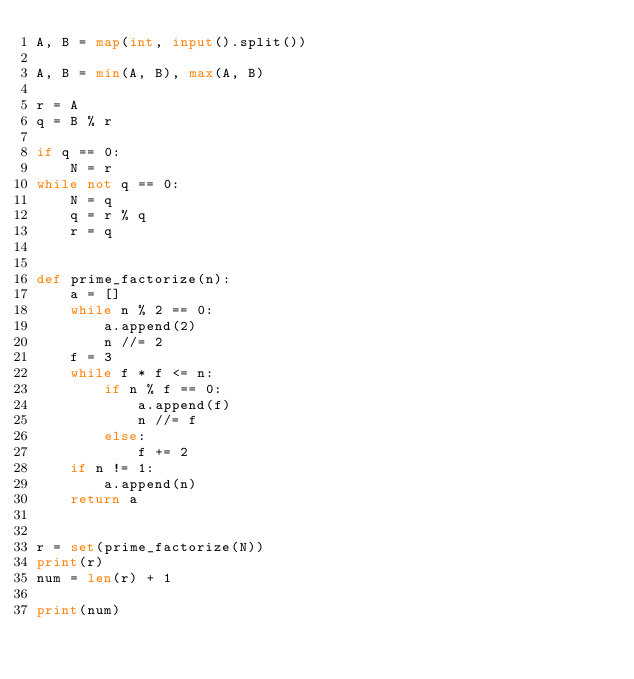<code> <loc_0><loc_0><loc_500><loc_500><_Python_>A, B = map(int, input().split())

A, B = min(A, B), max(A, B)

r = A
q = B % r

if q == 0:
    N = r
while not q == 0:
    N = q
    q = r % q
    r = q


def prime_factorize(n):
    a = []
    while n % 2 == 0:
        a.append(2)
        n //= 2
    f = 3
    while f * f <= n:
        if n % f == 0:
            a.append(f)
            n //= f
        else:
            f += 2
    if n != 1:
        a.append(n)
    return a


r = set(prime_factorize(N))
print(r)
num = len(r) + 1

print(num)
</code> 